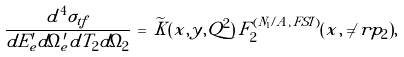Convert formula to latex. <formula><loc_0><loc_0><loc_500><loc_500>\frac { d ^ { 4 } \sigma _ { t f } } { d E _ { e } ^ { \prime } d \Omega _ { e } ^ { \prime } d T _ { 2 } d \Omega _ { 2 } } \, = \, { \widetilde { K } ( x , y , Q ^ { 2 } ) } \, F _ { 2 } ^ { ( N _ { 1 } / A , \, F S I ) } ( x , \ne r { p } _ { 2 } ) ,</formula> 